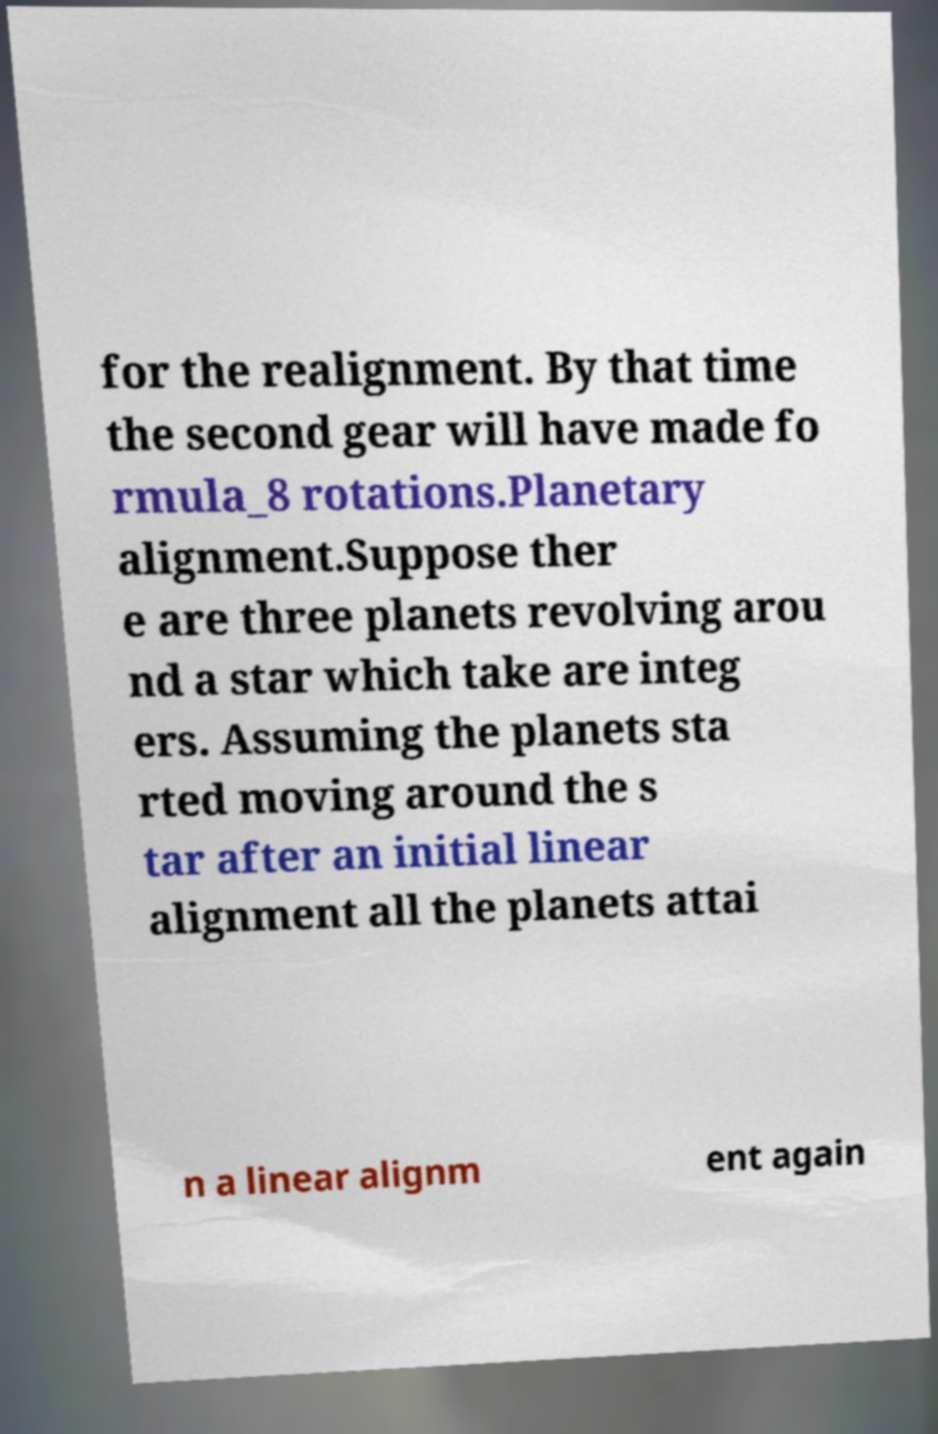Please identify and transcribe the text found in this image. for the realignment. By that time the second gear will have made fo rmula_8 rotations.Planetary alignment.Suppose ther e are three planets revolving arou nd a star which take are integ ers. Assuming the planets sta rted moving around the s tar after an initial linear alignment all the planets attai n a linear alignm ent again 